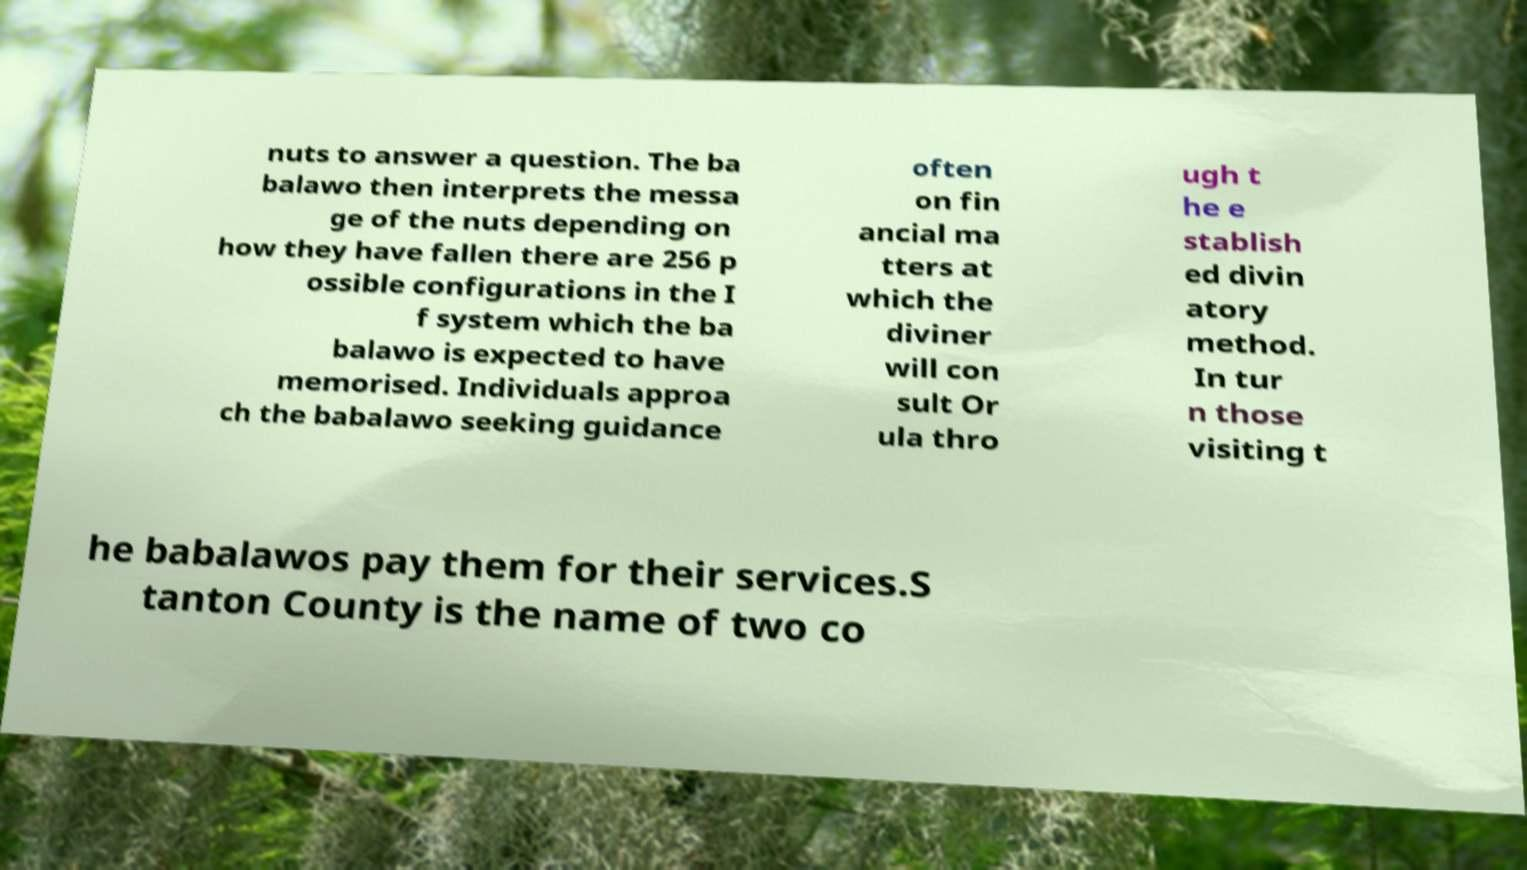Please read and relay the text visible in this image. What does it say? nuts to answer a question. The ba balawo then interprets the messa ge of the nuts depending on how they have fallen there are 256 p ossible configurations in the I f system which the ba balawo is expected to have memorised. Individuals approa ch the babalawo seeking guidance often on fin ancial ma tters at which the diviner will con sult Or ula thro ugh t he e stablish ed divin atory method. In tur n those visiting t he babalawos pay them for their services.S tanton County is the name of two co 